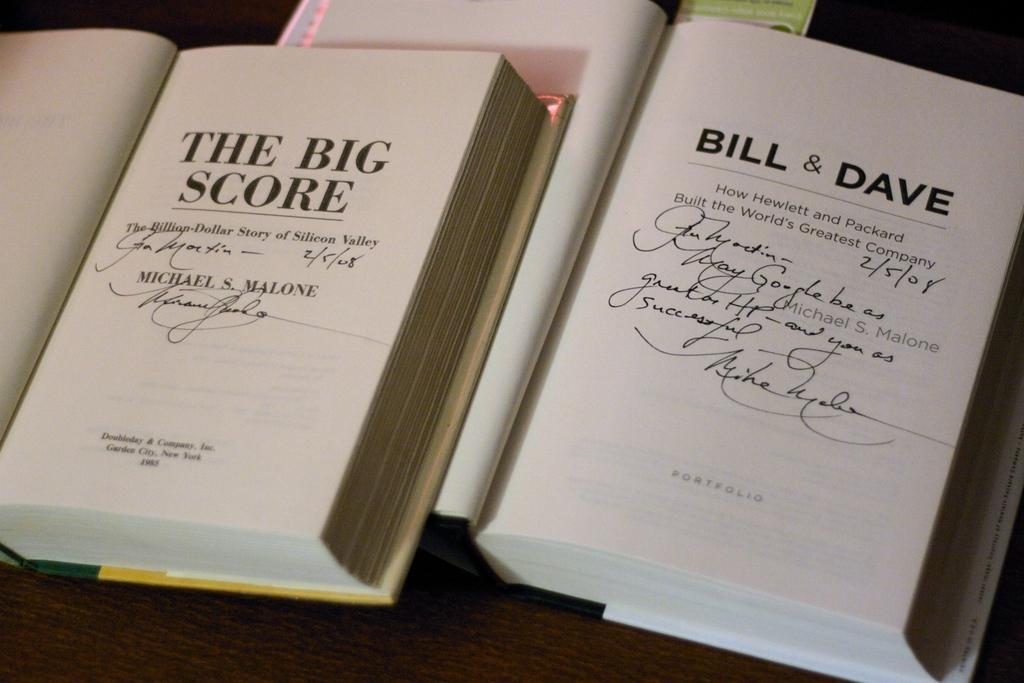<image>
Render a clear and concise summary of the photo. Two signed books, one of which is titled BILL & DAVE. 